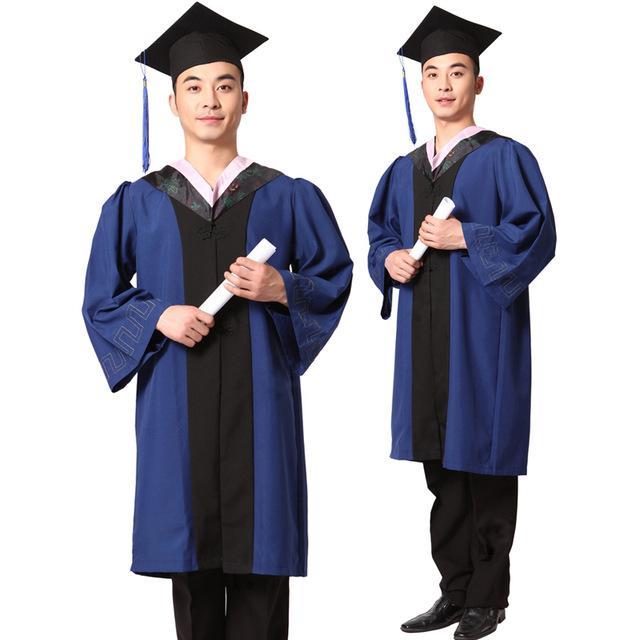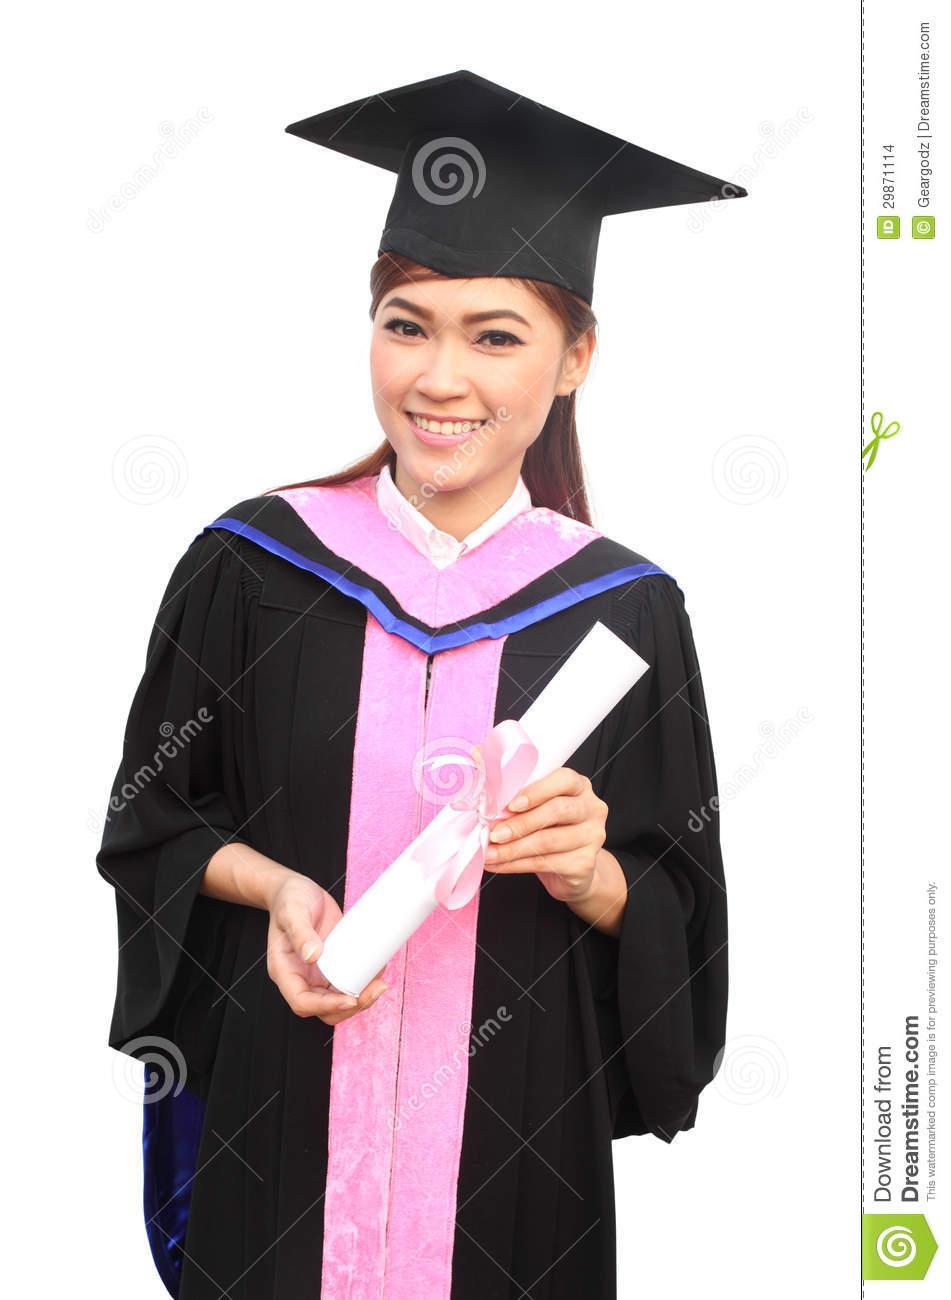The first image is the image on the left, the second image is the image on the right. For the images displayed, is the sentence "The full lengths of all graduation gowns are shown." factually correct? Answer yes or no. No. 